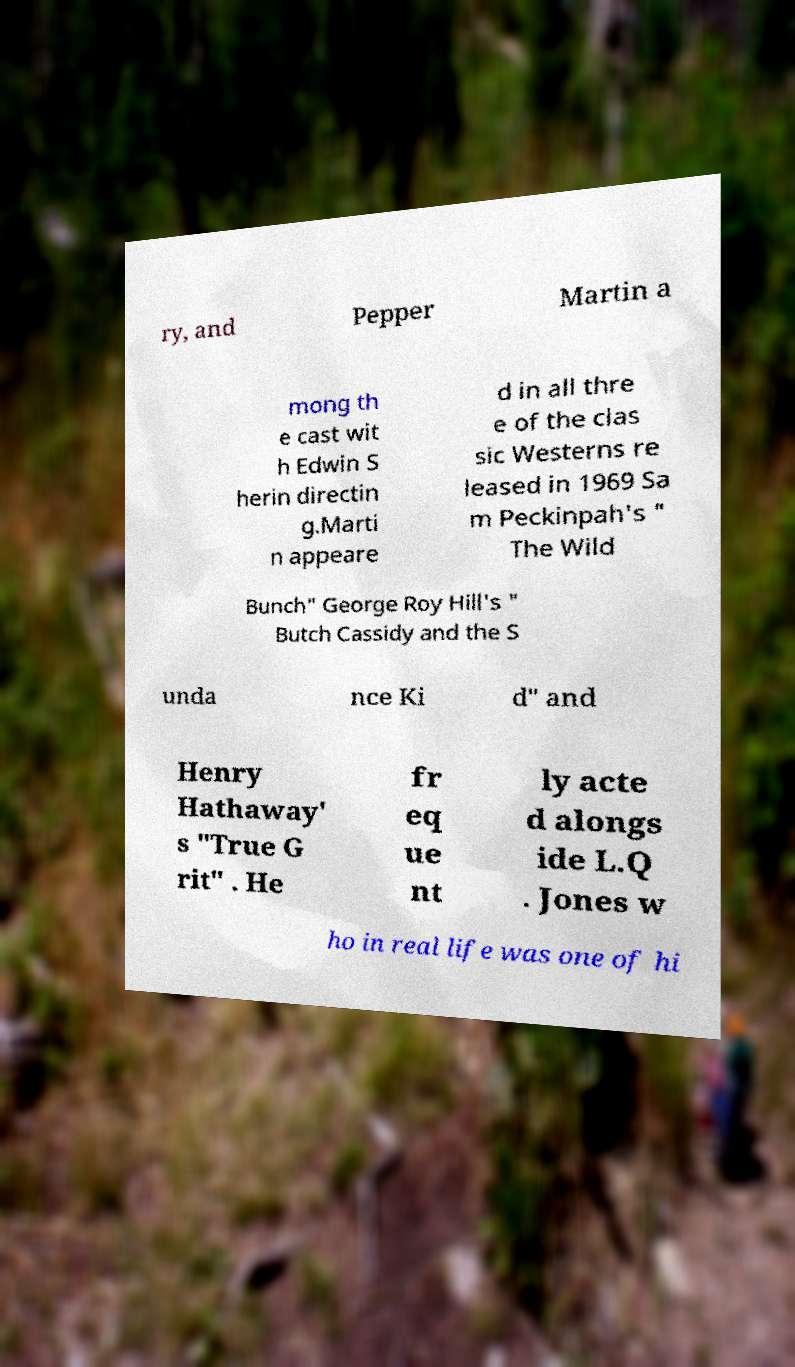I need the written content from this picture converted into text. Can you do that? ry, and Pepper Martin a mong th e cast wit h Edwin S herin directin g.Marti n appeare d in all thre e of the clas sic Westerns re leased in 1969 Sa m Peckinpah's " The Wild Bunch" George Roy Hill's " Butch Cassidy and the S unda nce Ki d" and Henry Hathaway' s "True G rit" . He fr eq ue nt ly acte d alongs ide L.Q . Jones w ho in real life was one of hi 